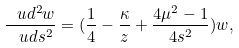<formula> <loc_0><loc_0><loc_500><loc_500>\frac { \ u d ^ { 2 } w } { \ u d s ^ { 2 } } = ( \frac { 1 } { 4 } - \frac { \kappa } { z } + \frac { 4 \mu ^ { 2 } - 1 } { 4 s ^ { 2 } } ) w ,</formula> 